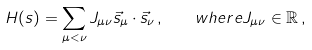<formula> <loc_0><loc_0><loc_500><loc_500>H ( { s } ) = \sum _ { \mu < \nu } J _ { \mu \nu } \vec { s } _ { \mu } \cdot \vec { s } _ { \nu } \, , \quad w h e r e J _ { \mu \nu } \in \mathbb { R } \, ,</formula> 